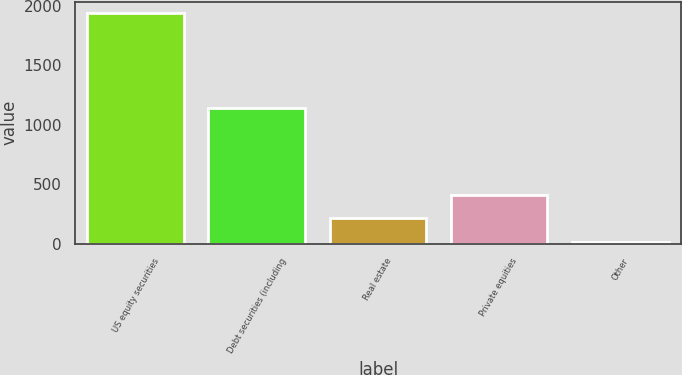<chart> <loc_0><loc_0><loc_500><loc_500><bar_chart><fcel>US equity securities<fcel>Debt securities (including<fcel>Real estate<fcel>Private equities<fcel>Other<nl><fcel>1939<fcel>1141<fcel>212<fcel>404.9<fcel>10<nl></chart> 